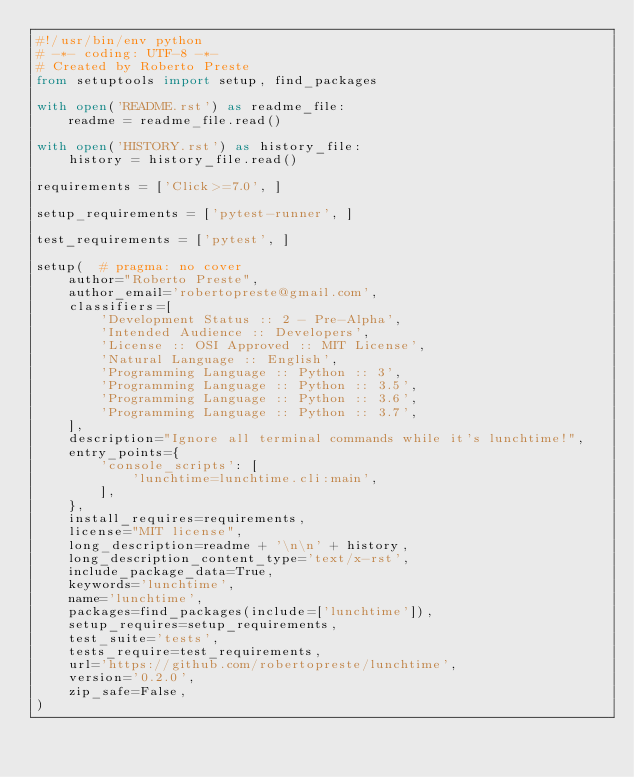Convert code to text. <code><loc_0><loc_0><loc_500><loc_500><_Python_>#!/usr/bin/env python
# -*- coding: UTF-8 -*-
# Created by Roberto Preste
from setuptools import setup, find_packages

with open('README.rst') as readme_file:
    readme = readme_file.read()

with open('HISTORY.rst') as history_file:
    history = history_file.read()

requirements = ['Click>=7.0', ]

setup_requirements = ['pytest-runner', ]

test_requirements = ['pytest', ]

setup(  # pragma: no cover
    author="Roberto Preste",
    author_email='robertopreste@gmail.com',
    classifiers=[
        'Development Status :: 2 - Pre-Alpha',
        'Intended Audience :: Developers',
        'License :: OSI Approved :: MIT License',
        'Natural Language :: English',
        'Programming Language :: Python :: 3',
        'Programming Language :: Python :: 3.5',
        'Programming Language :: Python :: 3.6',
        'Programming Language :: Python :: 3.7',
    ],
    description="Ignore all terminal commands while it's lunchtime!",
    entry_points={
        'console_scripts': [
            'lunchtime=lunchtime.cli:main',
        ],
    },
    install_requires=requirements,
    license="MIT license",
    long_description=readme + '\n\n' + history,
    long_description_content_type='text/x-rst',
    include_package_data=True,
    keywords='lunchtime',
    name='lunchtime',
    packages=find_packages(include=['lunchtime']),
    setup_requires=setup_requirements,
    test_suite='tests',
    tests_require=test_requirements,
    url='https://github.com/robertopreste/lunchtime',
    version='0.2.0',
    zip_safe=False,
)
</code> 